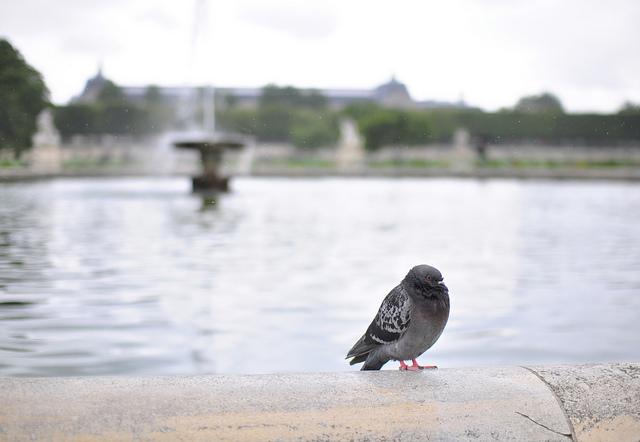Is the bird in motion?
Keep it brief. No. Is there a water body nearby?
Short answer required. Yes. What is the bird on?
Keep it brief. Concrete. 